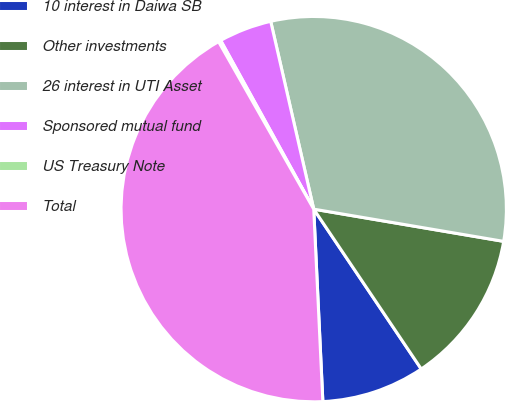<chart> <loc_0><loc_0><loc_500><loc_500><pie_chart><fcel>10 interest in Daiwa SB<fcel>Other investments<fcel>26 interest in UTI Asset<fcel>Sponsored mutual fund<fcel>US Treasury Note<fcel>Total<nl><fcel>8.67%<fcel>12.9%<fcel>31.26%<fcel>4.44%<fcel>0.2%<fcel>42.53%<nl></chart> 